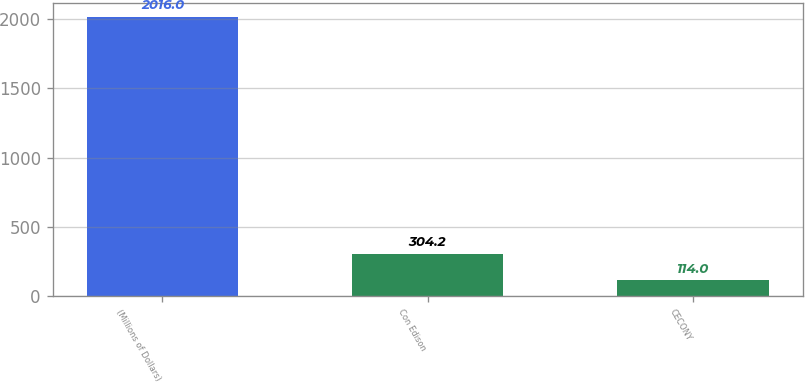<chart> <loc_0><loc_0><loc_500><loc_500><bar_chart><fcel>(Millions of Dollars)<fcel>Con Edison<fcel>CECONY<nl><fcel>2016<fcel>304.2<fcel>114<nl></chart> 